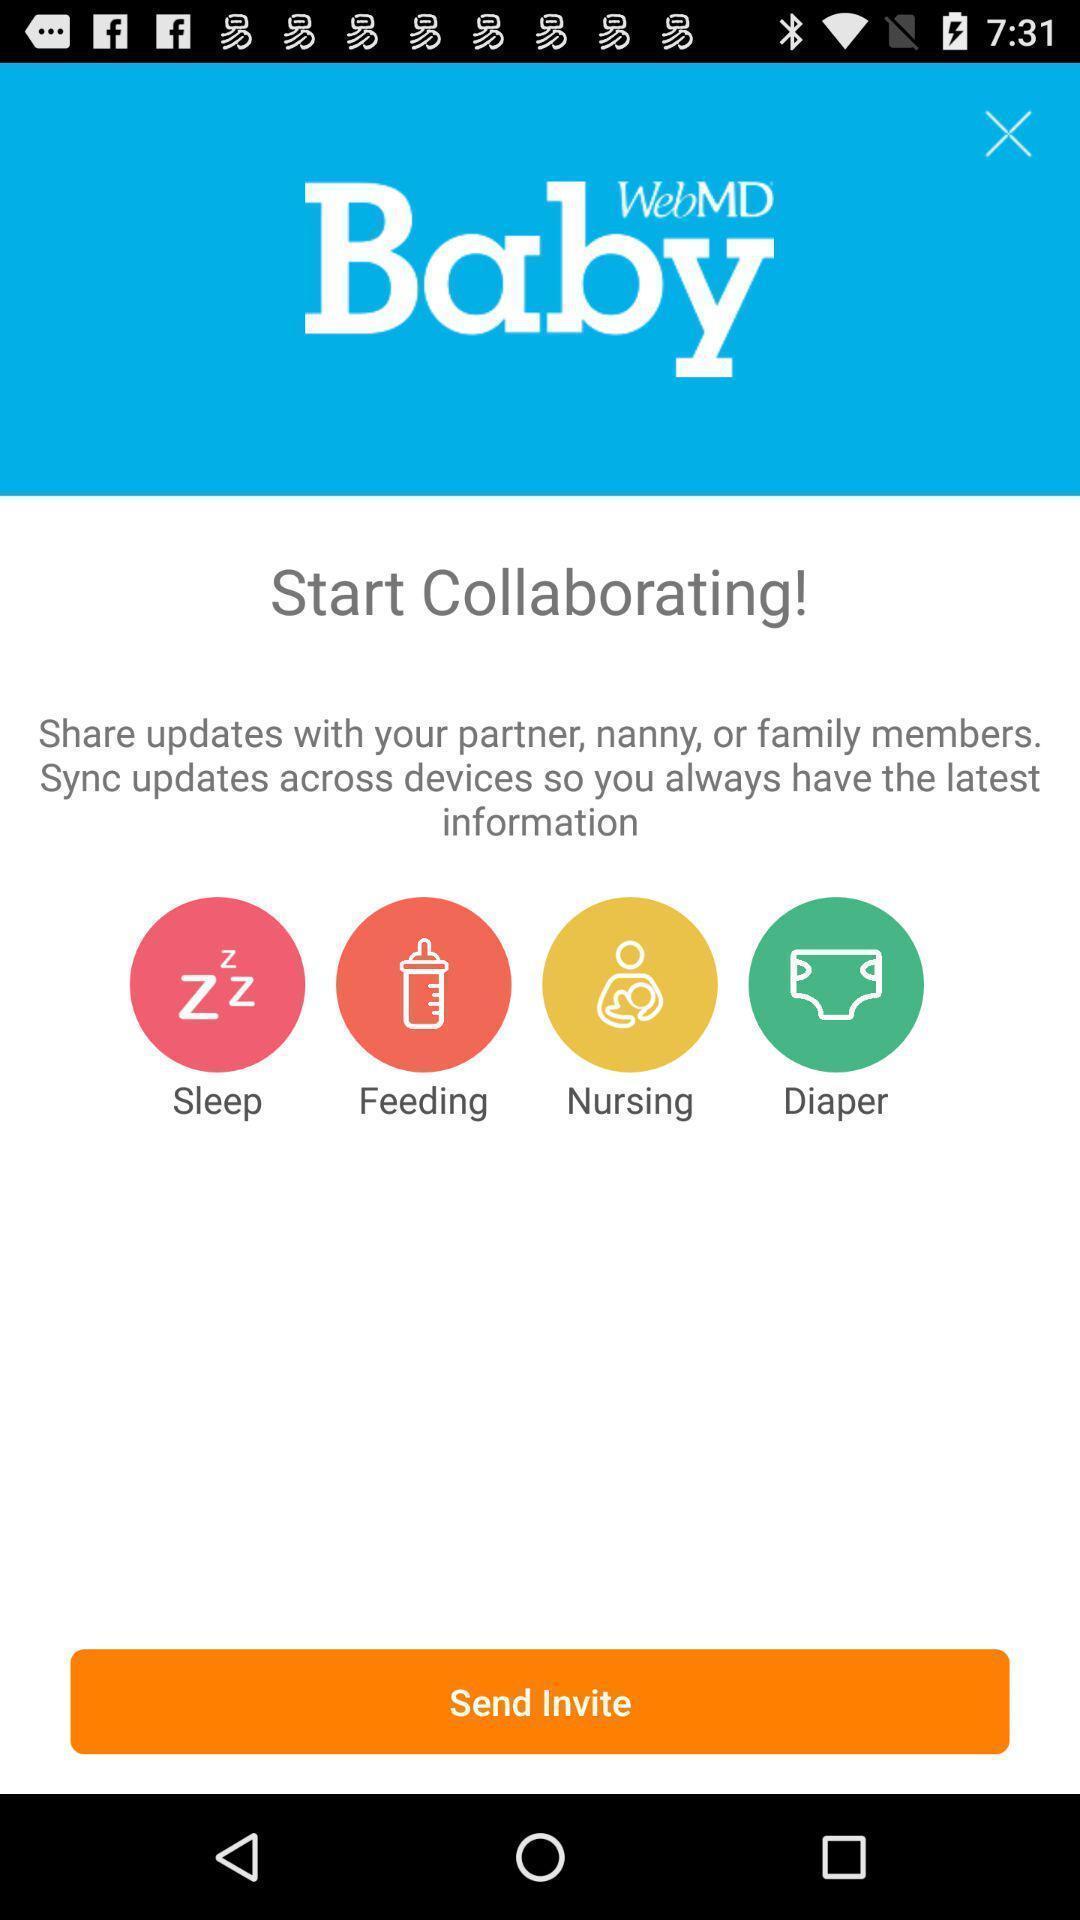Give me a summary of this screen capture. Welcome page of a baby app. 